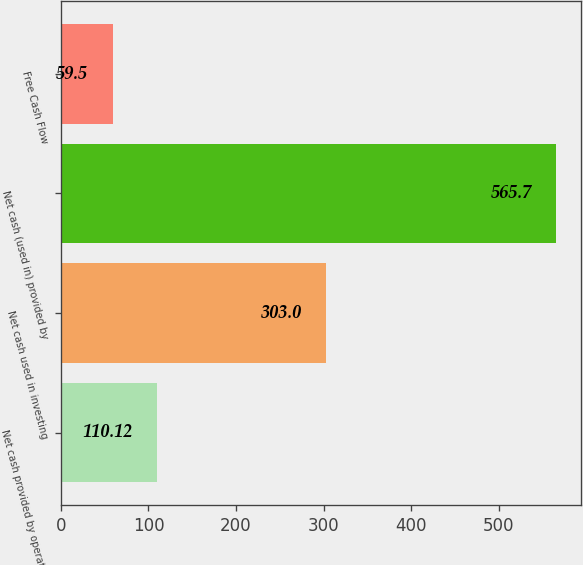Convert chart to OTSL. <chart><loc_0><loc_0><loc_500><loc_500><bar_chart><fcel>Net cash provided by operating<fcel>Net cash used in investing<fcel>Net cash (used in) provided by<fcel>Free Cash Flow<nl><fcel>110.12<fcel>303<fcel>565.7<fcel>59.5<nl></chart> 